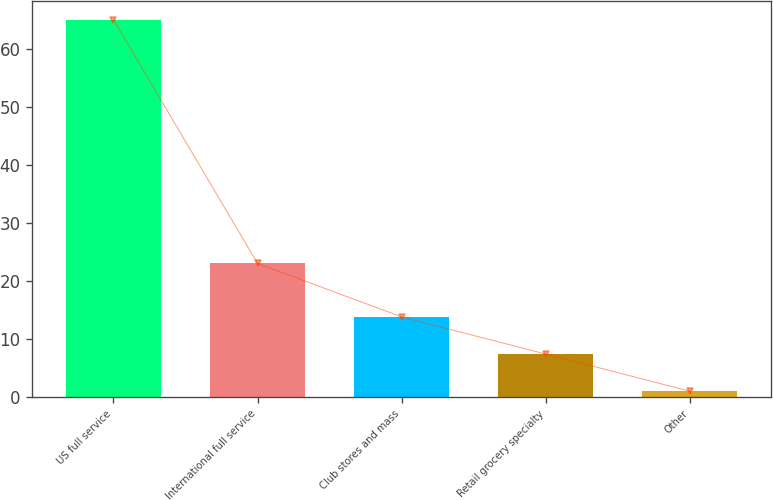Convert chart to OTSL. <chart><loc_0><loc_0><loc_500><loc_500><bar_chart><fcel>US full service<fcel>International full service<fcel>Club stores and mass<fcel>Retail grocery specialty<fcel>Other<nl><fcel>65<fcel>23<fcel>13.8<fcel>7.4<fcel>1<nl></chart> 